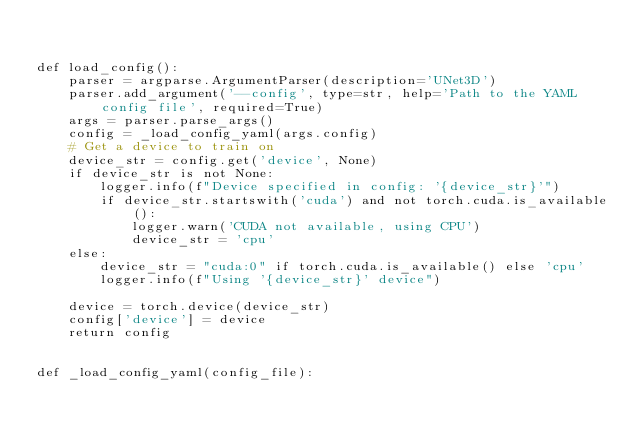<code> <loc_0><loc_0><loc_500><loc_500><_Python_>

def load_config():
    parser = argparse.ArgumentParser(description='UNet3D')
    parser.add_argument('--config', type=str, help='Path to the YAML config file', required=True)
    args = parser.parse_args()
    config = _load_config_yaml(args.config)
    # Get a device to train on
    device_str = config.get('device', None)
    if device_str is not None:
        logger.info(f"Device specified in config: '{device_str}'")
        if device_str.startswith('cuda') and not torch.cuda.is_available():
            logger.warn('CUDA not available, using CPU')
            device_str = 'cpu'
    else:
        device_str = "cuda:0" if torch.cuda.is_available() else 'cpu'
        logger.info(f"Using '{device_str}' device")

    device = torch.device(device_str)
    config['device'] = device
    return config


def _load_config_yaml(config_file):</code> 